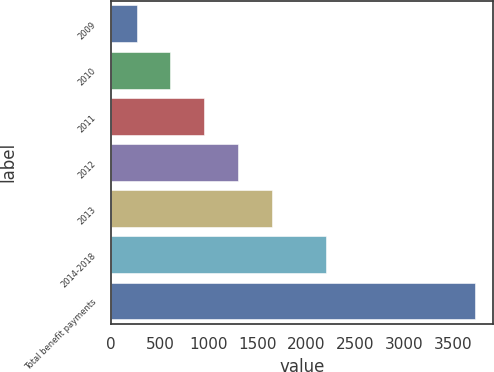<chart> <loc_0><loc_0><loc_500><loc_500><bar_chart><fcel>2009<fcel>2010<fcel>2011<fcel>2012<fcel>2013<fcel>2014-2018<fcel>Total benefit payments<nl><fcel>263<fcel>608.4<fcel>953.8<fcel>1299.2<fcel>1644.6<fcel>2203<fcel>3717<nl></chart> 